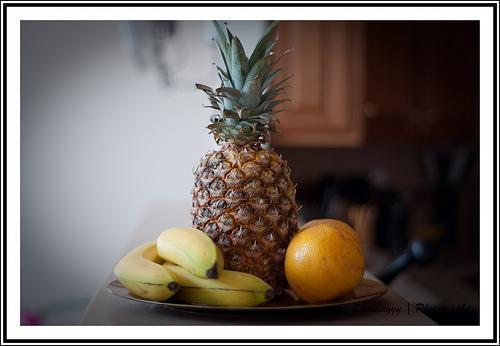What kind of tall fruit is in the center of the fruit plate?
Select the correct answer and articulate reasoning with the following format: 'Answer: answer
Rationale: rationale.'
Options: Pineapple, banana, apple, strawberry. Answer: pineapple.
Rationale: The tallest fruit on the plate is a pineapple. With which fruit would be most connected to Costa Rica?
Make your selection from the four choices given to correctly answer the question.
Options: Orange, banana, pineapple, apple. Pineapple. 